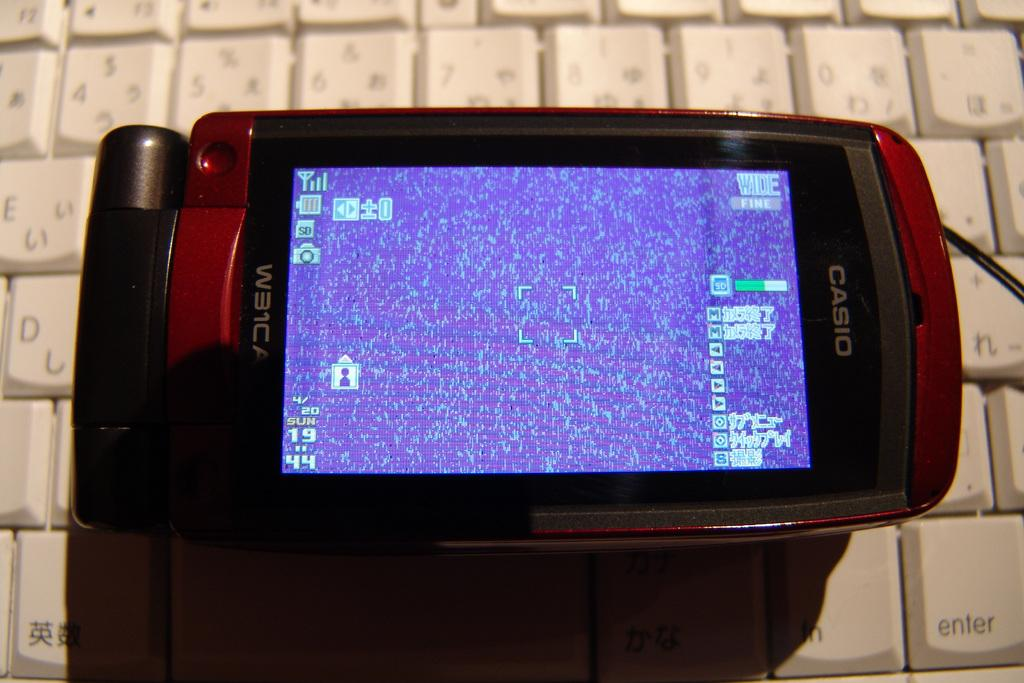<image>
Describe the image concisely. A Casio cell phone with a solitare game on the screen. 